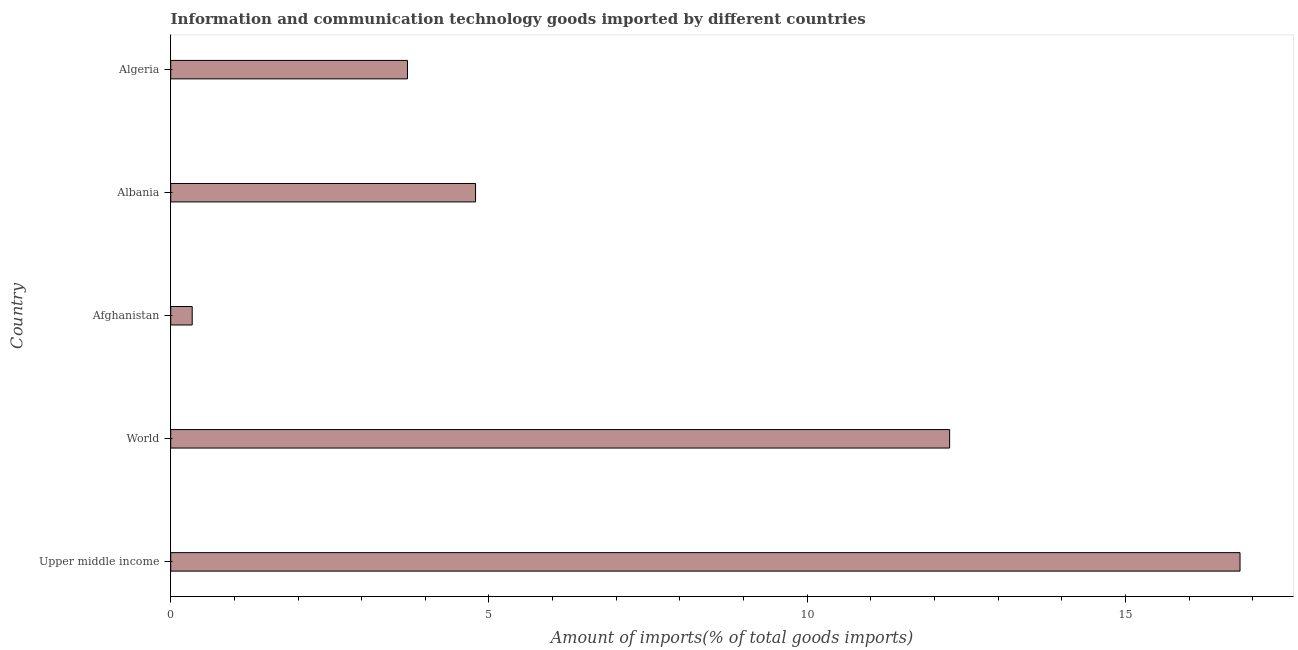Does the graph contain any zero values?
Give a very brief answer. No. Does the graph contain grids?
Provide a succinct answer. No. What is the title of the graph?
Ensure brevity in your answer.  Information and communication technology goods imported by different countries. What is the label or title of the X-axis?
Provide a succinct answer. Amount of imports(% of total goods imports). What is the amount of ict goods imports in World?
Your answer should be very brief. 12.24. Across all countries, what is the maximum amount of ict goods imports?
Your answer should be compact. 16.8. Across all countries, what is the minimum amount of ict goods imports?
Your answer should be very brief. 0.34. In which country was the amount of ict goods imports maximum?
Your response must be concise. Upper middle income. In which country was the amount of ict goods imports minimum?
Your answer should be very brief. Afghanistan. What is the sum of the amount of ict goods imports?
Provide a short and direct response. 37.88. What is the difference between the amount of ict goods imports in Upper middle income and World?
Provide a short and direct response. 4.56. What is the average amount of ict goods imports per country?
Ensure brevity in your answer.  7.58. What is the median amount of ict goods imports?
Give a very brief answer. 4.79. In how many countries, is the amount of ict goods imports greater than 7 %?
Keep it short and to the point. 2. What is the ratio of the amount of ict goods imports in Algeria to that in Upper middle income?
Your response must be concise. 0.22. What is the difference between the highest and the second highest amount of ict goods imports?
Give a very brief answer. 4.56. Is the sum of the amount of ict goods imports in Albania and Algeria greater than the maximum amount of ict goods imports across all countries?
Provide a succinct answer. No. What is the difference between the highest and the lowest amount of ict goods imports?
Offer a very short reply. 16.46. In how many countries, is the amount of ict goods imports greater than the average amount of ict goods imports taken over all countries?
Ensure brevity in your answer.  2. How many countries are there in the graph?
Provide a succinct answer. 5. What is the difference between two consecutive major ticks on the X-axis?
Provide a succinct answer. 5. Are the values on the major ticks of X-axis written in scientific E-notation?
Keep it short and to the point. No. What is the Amount of imports(% of total goods imports) of Upper middle income?
Offer a terse response. 16.8. What is the Amount of imports(% of total goods imports) of World?
Your response must be concise. 12.24. What is the Amount of imports(% of total goods imports) of Afghanistan?
Offer a very short reply. 0.34. What is the Amount of imports(% of total goods imports) of Albania?
Make the answer very short. 4.79. What is the Amount of imports(% of total goods imports) of Algeria?
Your answer should be compact. 3.72. What is the difference between the Amount of imports(% of total goods imports) in Upper middle income and World?
Your response must be concise. 4.56. What is the difference between the Amount of imports(% of total goods imports) in Upper middle income and Afghanistan?
Offer a very short reply. 16.46. What is the difference between the Amount of imports(% of total goods imports) in Upper middle income and Albania?
Your answer should be compact. 12.01. What is the difference between the Amount of imports(% of total goods imports) in Upper middle income and Algeria?
Make the answer very short. 13.08. What is the difference between the Amount of imports(% of total goods imports) in World and Afghanistan?
Offer a very short reply. 11.9. What is the difference between the Amount of imports(% of total goods imports) in World and Albania?
Your answer should be very brief. 7.45. What is the difference between the Amount of imports(% of total goods imports) in World and Algeria?
Ensure brevity in your answer.  8.52. What is the difference between the Amount of imports(% of total goods imports) in Afghanistan and Albania?
Make the answer very short. -4.45. What is the difference between the Amount of imports(% of total goods imports) in Afghanistan and Algeria?
Give a very brief answer. -3.38. What is the difference between the Amount of imports(% of total goods imports) in Albania and Algeria?
Make the answer very short. 1.07. What is the ratio of the Amount of imports(% of total goods imports) in Upper middle income to that in World?
Offer a terse response. 1.37. What is the ratio of the Amount of imports(% of total goods imports) in Upper middle income to that in Afghanistan?
Ensure brevity in your answer.  49.76. What is the ratio of the Amount of imports(% of total goods imports) in Upper middle income to that in Albania?
Keep it short and to the point. 3.51. What is the ratio of the Amount of imports(% of total goods imports) in Upper middle income to that in Algeria?
Give a very brief answer. 4.52. What is the ratio of the Amount of imports(% of total goods imports) in World to that in Afghanistan?
Ensure brevity in your answer.  36.24. What is the ratio of the Amount of imports(% of total goods imports) in World to that in Albania?
Provide a succinct answer. 2.56. What is the ratio of the Amount of imports(% of total goods imports) in World to that in Algeria?
Offer a terse response. 3.29. What is the ratio of the Amount of imports(% of total goods imports) in Afghanistan to that in Albania?
Ensure brevity in your answer.  0.07. What is the ratio of the Amount of imports(% of total goods imports) in Afghanistan to that in Algeria?
Offer a very short reply. 0.09. What is the ratio of the Amount of imports(% of total goods imports) in Albania to that in Algeria?
Keep it short and to the point. 1.29. 